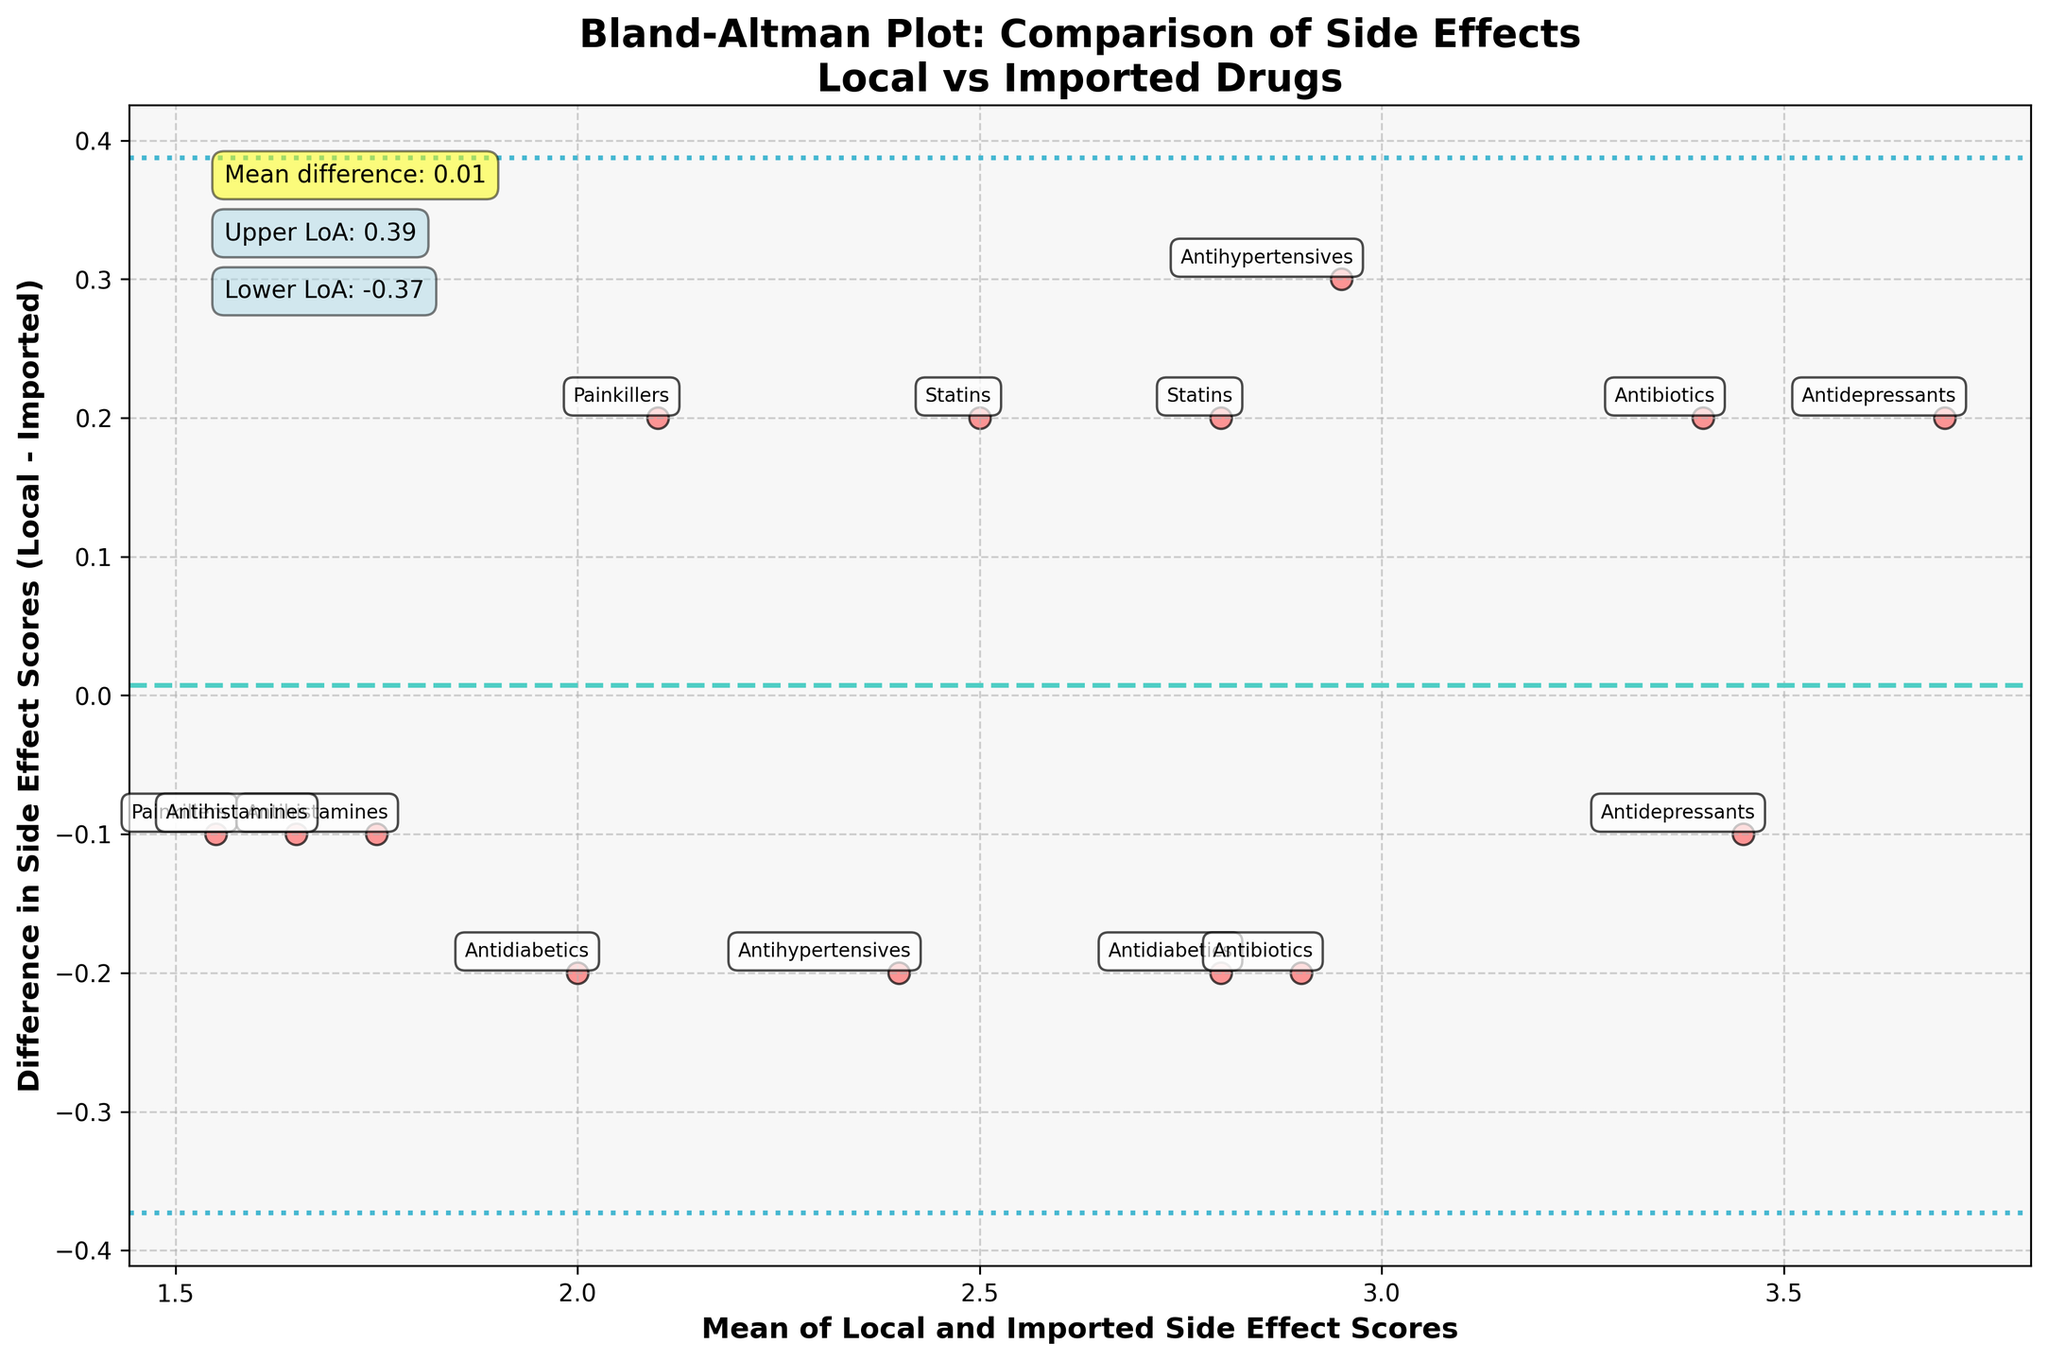What is the title of the plot? The title is usually placed at the top of the figure and provides a concise summary of the main focus of the plot.
Answer: Bland-Altman Plot: Comparison of Side Effects Local vs Imported Drugs How many data points are there in the plot? Each distinct scattered point on the plot represents a unique data point. Count the number of distinct points to get the total.
Answer: 14 What does the x-axis represent? The x-axis is labeled and shows what the corresponding values mean within the context of the compared variables.
Answer: Mean of Local and Imported Side Effect Scores What does the y-axis represent? The y-axis is labeled, showing what the corresponding values mean regarding the comparison between the two variables.
Answer: Difference in Side Effect Scores (Local - Imported) Which Drug Class is represented by the point with the highest mean side effect score? Locate the point furthest to the right on the x-axis, as it represents the highest mean score and identify its Drug Class annotation.
Answer: Antidepressants (Escitalopram - Cipralex) What are the upper and lower limits of agreement in this plot? These limits are identified by horizontal dashed lines in a specific color and are usually annotated on the plot itself. Their values mark the range within which most differences fall.
Answer: Upper LoA: 0.32, Lower LoA: -0.46 What is the mean difference between the Local and Imported Side Effect Scores? This is represented by a horizontal central line, often noted with an annotation on the plot.
Answer: -0.07 How do the side effects of antibiotics (Azithromycin and Amoxicillin) compare between local and imported brands? Look for the Antibiotics drug class points and observe their position relative to the y=0 line, which indicates if the local brand has more or fewer side effects.
Answer: Azithromycin (Local - Imported = 0.2), Amoxicillin (Local - Imported = -0.2) Is there any drug class where the local brand consistently shows fewer side effects than the imported brand? Observe the scatter points for each drug class and see if any particular category consistently appears below the y=0 line.
Answer: Antidepressants (Escitalopram - Cipralex, Fluoxetine - Fludac) Which drug class has the smallest difference in side effect scores between local and imported brands? Find the point closest to the y=0 line, which indicates the smallest difference between the local and imported brands.
Answer: Painkillers (Paracetamol - Calpol) Are there any drug classes where local brands have higher mean side effect scores than imported brands? Points above the y=0 line indicate that the local brand has higher side effect scores. Check the annotations to identify these drug classes.
Answer: Painkillers, Antidepressants 